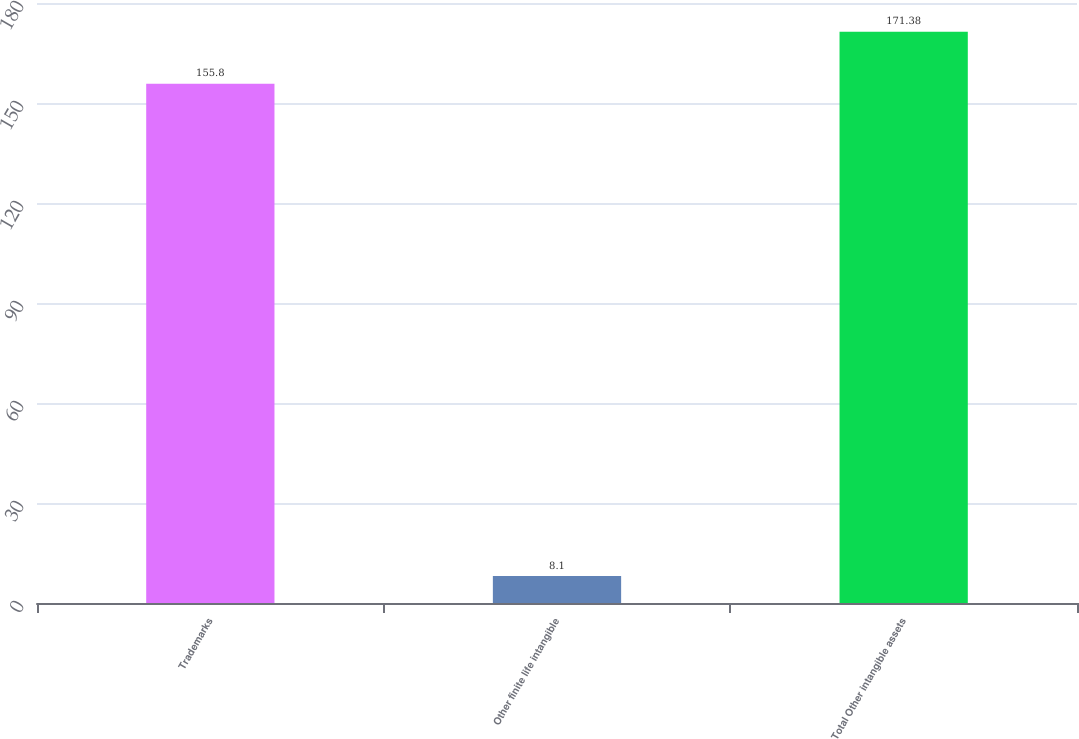Convert chart to OTSL. <chart><loc_0><loc_0><loc_500><loc_500><bar_chart><fcel>Trademarks<fcel>Other finite life intangible<fcel>Total Other intangible assets<nl><fcel>155.8<fcel>8.1<fcel>171.38<nl></chart> 